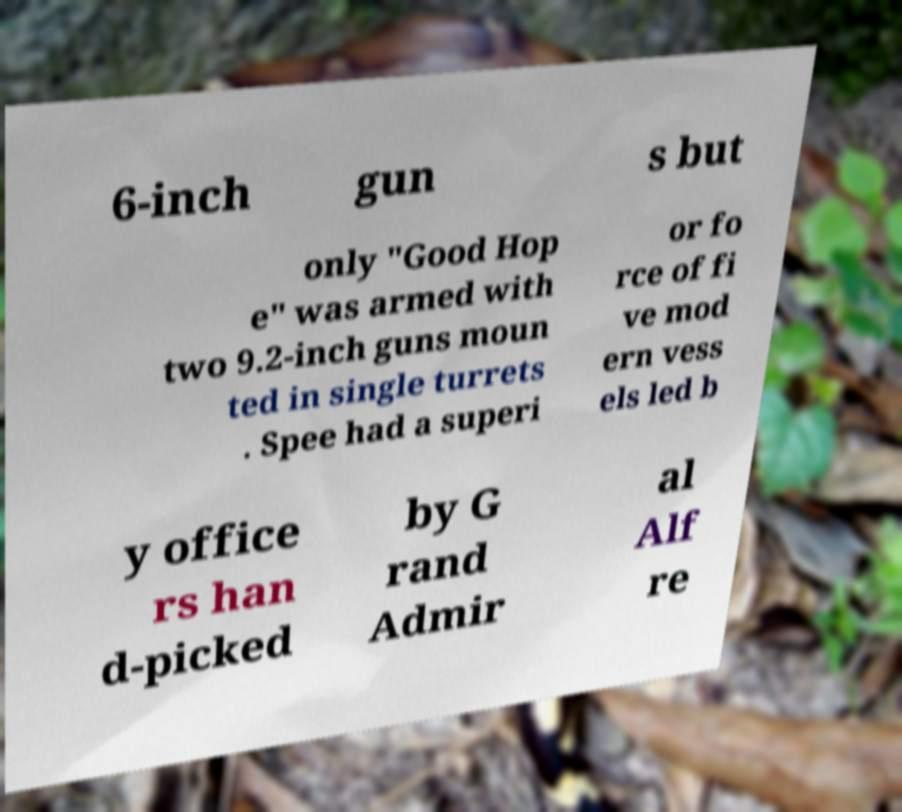Please read and relay the text visible in this image. What does it say? 6-inch gun s but only "Good Hop e" was armed with two 9.2-inch guns moun ted in single turrets . Spee had a superi or fo rce of fi ve mod ern vess els led b y office rs han d-picked by G rand Admir al Alf re 